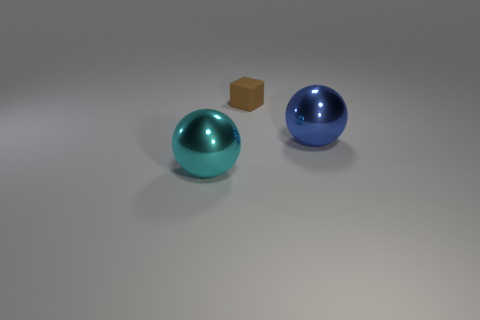How many tiny brown blocks are left of the shiny object that is to the right of the brown cube behind the cyan sphere? Upon examining the scene, there is one small brown block positioned to the left of the shiny, reflective blue sphere. To describe the layout more precisely, the scenery includes a cyan sphere at the forefront, behind which is a small brown cube. To the right of this cube, and slightly further back, lies the blue sphere which reflects light, creating highlights on its surface. To the left of this blue sphere—and this is crucial to answering your question—is the single tiny brown block in question. There are no other tiny brown blocks in this specific spatial arrangement. 